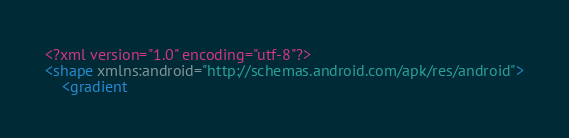Convert code to text. <code><loc_0><loc_0><loc_500><loc_500><_XML_><?xml version="1.0" encoding="utf-8"?>
<shape xmlns:android="http://schemas.android.com/apk/res/android">
    <gradient</code> 